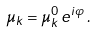<formula> <loc_0><loc_0><loc_500><loc_500>\mu _ { k } = \mu ^ { 0 } _ { k } \, e ^ { i \varphi } \, .</formula> 